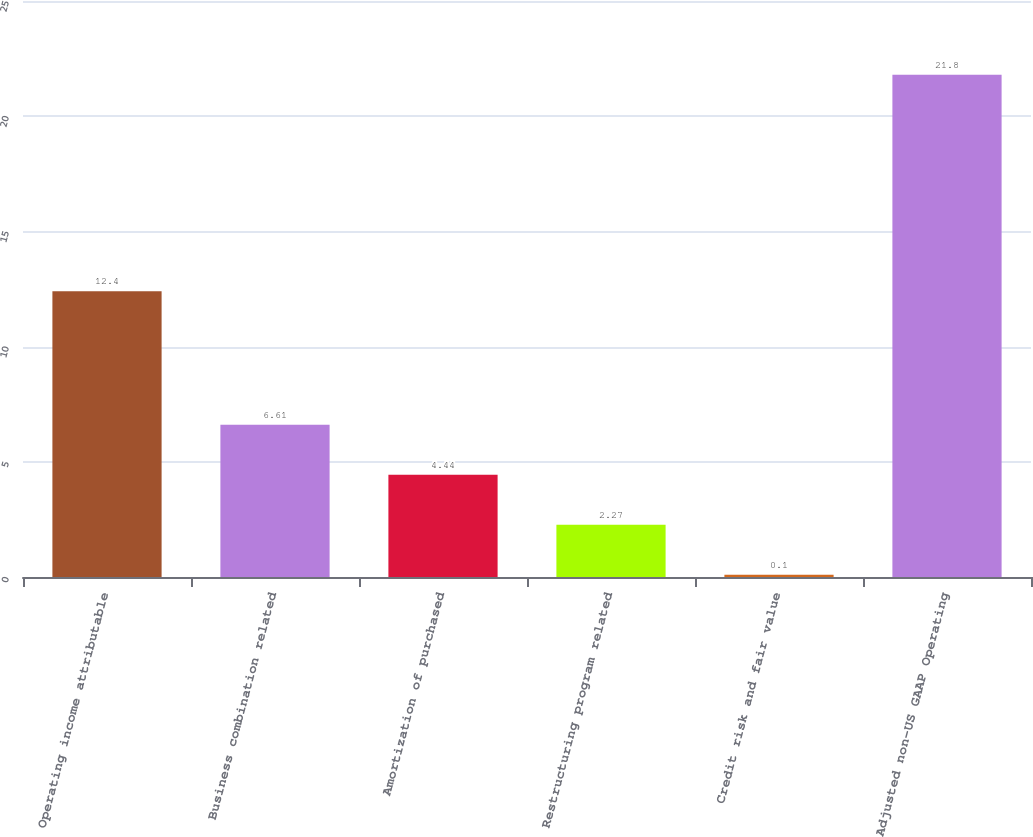Convert chart. <chart><loc_0><loc_0><loc_500><loc_500><bar_chart><fcel>Operating income attributable<fcel>Business combination related<fcel>Amortization of purchased<fcel>Restructuring program related<fcel>Credit risk and fair value<fcel>Adjusted non-US GAAP Operating<nl><fcel>12.4<fcel>6.61<fcel>4.44<fcel>2.27<fcel>0.1<fcel>21.8<nl></chart> 